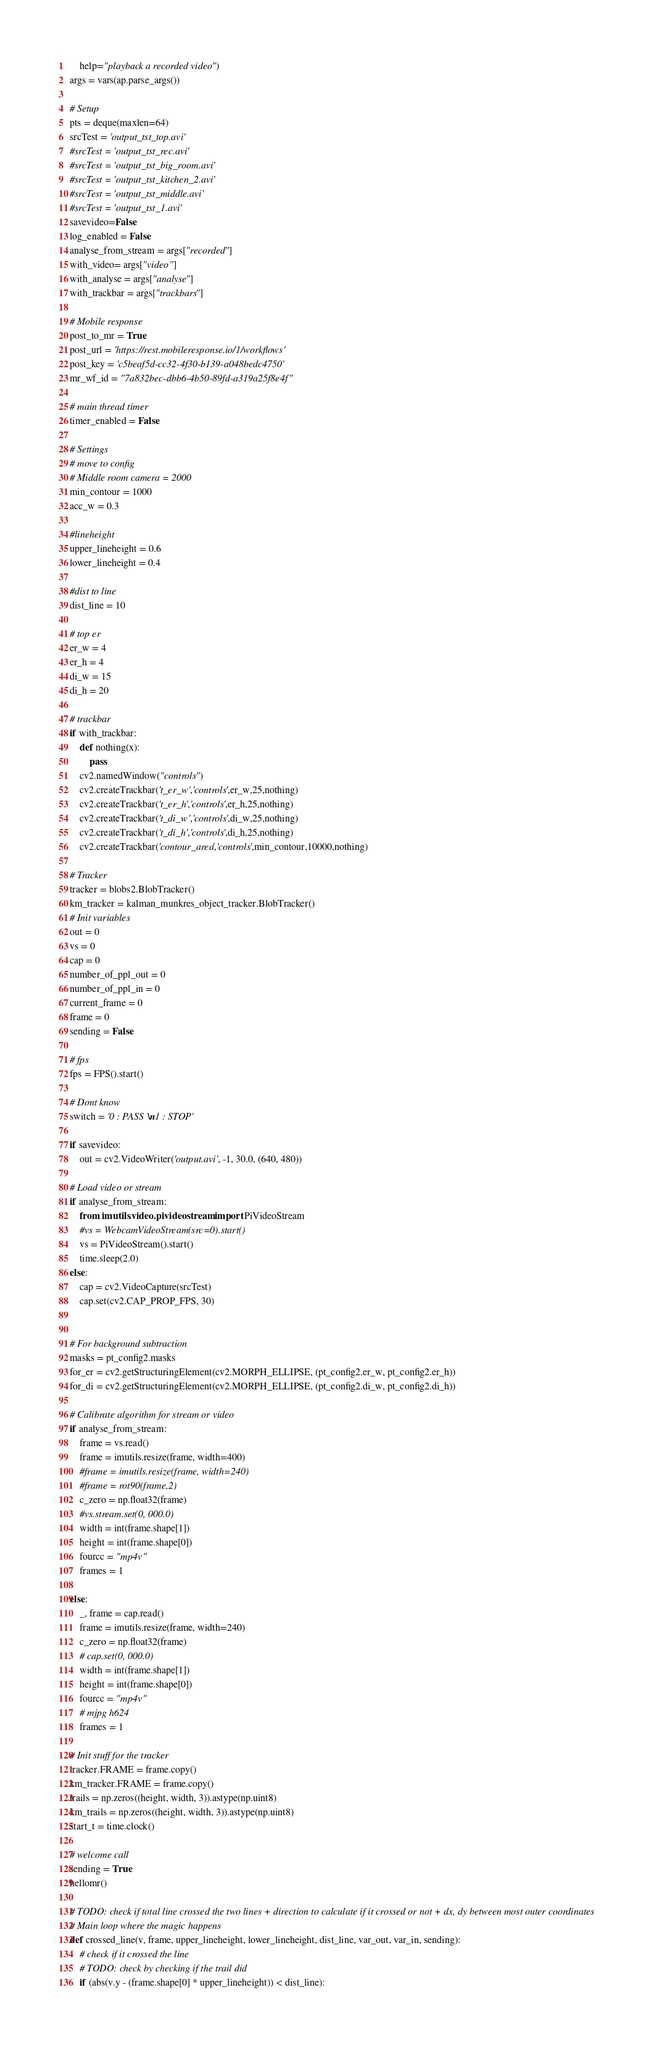Convert code to text. <code><loc_0><loc_0><loc_500><loc_500><_Python_>	help="playback a recorded video")
args = vars(ap.parse_args())

# Setup
pts = deque(maxlen=64)
srcTest = 'output_tst_top.avi'
#srcTest = 'output_tst_rec.avi'
#srcTest = 'output_tst_big_room.avi'
#srcTest = 'output_tst_kitchen_2.avi'
#srcTest = 'output_tst_middle.avi'
#srcTest = 'output_tst_1.avi'
savevideo=False
log_enabled = False
analyse_from_stream = args["recorded"]
with_video= args["video"]
with_analyse = args["analyse"]
with_trackbar = args["trackbars"]

# Mobile response
post_to_mr = True
post_url = 'https://rest.mobileresponse.io/1/workflows'
post_key = 'c5beaf5d-cc32-4f30-b139-a048bedc4750'
mr_wf_id = "7a832bec-dbb6-4b50-89fd-a319a25f8e4f"

# main thread timer
timer_enabled = False

# Settings
# move to config
# Middle room camera = 2000
min_contour = 1000
acc_w = 0.3

#lineheight
upper_lineheight = 0.6
lower_lineheight = 0.4

#dist to line
dist_line = 10

# top er
er_w = 4
er_h = 4
di_w = 15
di_h = 20

# trackbar
if with_trackbar:
    def nothing(x):
        pass
    cv2.namedWindow("controls")
    cv2.createTrackbar('t_er_w','controls',er_w,25,nothing)
    cv2.createTrackbar('t_er_h','controls',er_h,25,nothing)
    cv2.createTrackbar('t_di_w','controls',di_w,25,nothing)
    cv2.createTrackbar('t_di_h','controls',di_h,25,nothing)
    cv2.createTrackbar('contour_area','controls',min_contour,10000,nothing)

# Tracker
tracker = blobs2.BlobTracker()
km_tracker = kalman_munkres_object_tracker.BlobTracker()
# Init variables
out = 0
vs = 0
cap = 0
number_of_ppl_out = 0
number_of_ppl_in = 0
current_frame = 0
frame = 0
sending = False

# fps
fps = FPS().start()

# Dont know
switch = '0 : PASS \n1 : STOP'

if savevideo:
    out = cv2.VideoWriter('output.avi', -1, 30.0, (640, 480))

# Load video or stream
if analyse_from_stream:
    from imutils.video.pivideostream import PiVideoStream
    #vs = WebcamVideoStream(src=0).start()
    vs = PiVideoStream().start()
    time.sleep(2.0)
else:
    cap = cv2.VideoCapture(srcTest)
    cap.set(cv2.CAP_PROP_FPS, 30)


# For background subtraction
masks = pt_config2.masks
for_er = cv2.getStructuringElement(cv2.MORPH_ELLIPSE, (pt_config2.er_w, pt_config2.er_h))
for_di = cv2.getStructuringElement(cv2.MORPH_ELLIPSE, (pt_config2.di_w, pt_config2.di_h))

# Calibrate algorithm for stream or video
if analyse_from_stream:
    frame = vs.read()
    frame = imutils.resize(frame, width=400)
    #frame = imutils.resize(frame, width=240)
    #frame = rot90(frame,2)
    c_zero = np.float32(frame)
    #vs.stream.set(0, 000.0)
    width = int(frame.shape[1])
    height = int(frame.shape[0])
    fourcc = "mp4v"
    frames = 1

else:
    _, frame = cap.read()
    frame = imutils.resize(frame, width=240)
    c_zero = np.float32(frame)
    # cap.set(0, 000.0)
    width = int(frame.shape[1])
    height = int(frame.shape[0])
    fourcc = "mp4v"
    # mjpg h624
    frames = 1

# Init stuff for the tracker
tracker.FRAME = frame.copy()
km_tracker.FRAME = frame.copy()
trails = np.zeros((height, width, 3)).astype(np.uint8)
km_trails = np.zeros((height, width, 3)).astype(np.uint8)
start_t = time.clock()

# welcome call
sending = True
hellomr()

# TODO: check if total line crossed the two lines + direction to calculate if it crossed or not + dx, dy between most outer coordinates
# Main loop where the magic happens
def crossed_line(v, frame, upper_lineheight, lower_lineheight, dist_line, var_out, var_in, sending):
    # check if it crossed the line
    # TODO: check by checking if the trail did
    if (abs(v.y - (frame.shape[0] * upper_lineheight)) < dist_line):</code> 